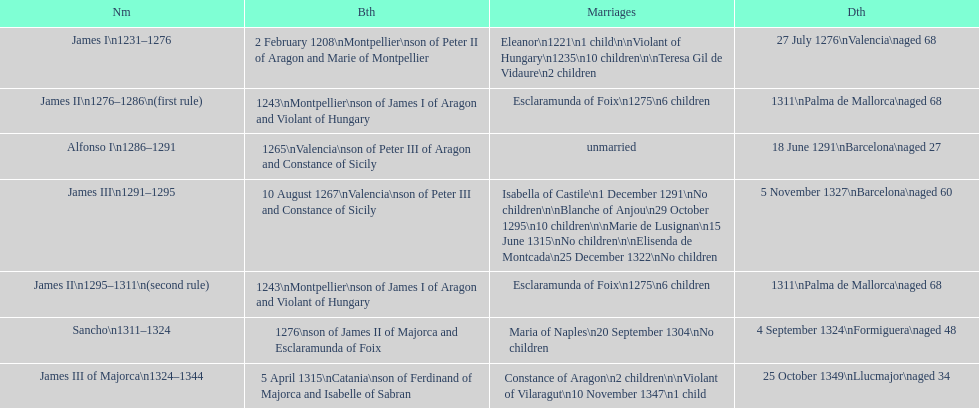In 1276, was james iii or sancho the one who was born? Sancho. 